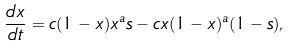Convert formula to latex. <formula><loc_0><loc_0><loc_500><loc_500>\frac { d x } { d t } = c ( 1 - x ) x ^ { a } s - c x ( 1 - x ) ^ { a } ( 1 - s ) ,</formula> 